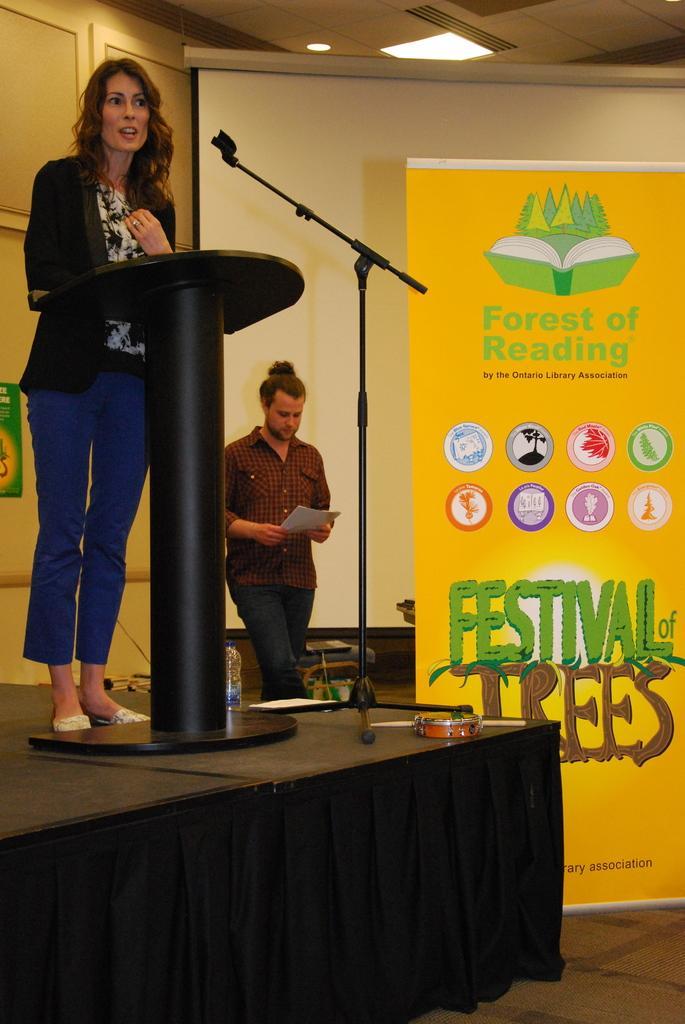Please provide a concise description of this image. In this image we can see a woman standing on the stage. We can also see a speaker stand, the musical instrument, a bottle and a stand on the stage. We can also see a banner with some text on it, a person standing holding some papers, a wall, a display screen and a roof with some ceiling lights. 